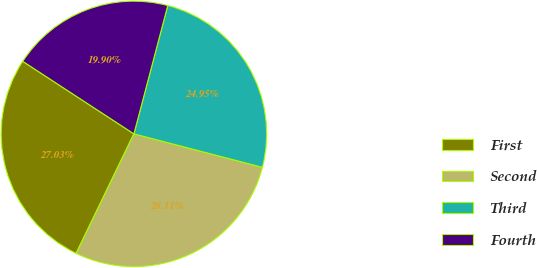Convert chart to OTSL. <chart><loc_0><loc_0><loc_500><loc_500><pie_chart><fcel>First<fcel>Second<fcel>Third<fcel>Fourth<nl><fcel>27.03%<fcel>28.11%<fcel>24.95%<fcel>19.9%<nl></chart> 